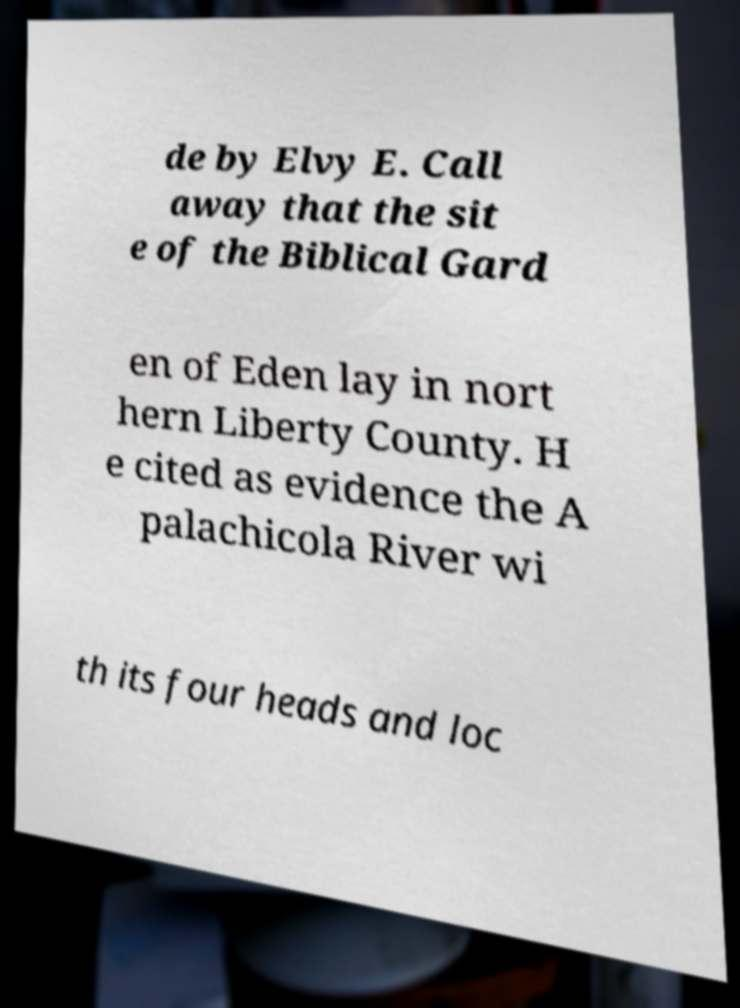Please identify and transcribe the text found in this image. de by Elvy E. Call away that the sit e of the Biblical Gard en of Eden lay in nort hern Liberty County. H e cited as evidence the A palachicola River wi th its four heads and loc 